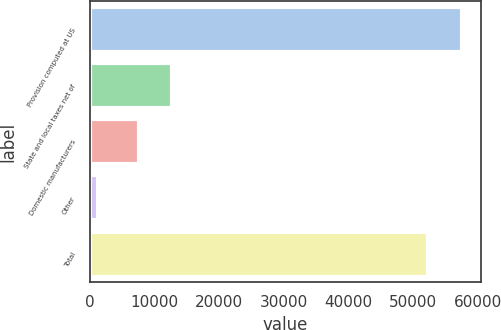Convert chart to OTSL. <chart><loc_0><loc_0><loc_500><loc_500><bar_chart><fcel>Provision computed at US<fcel>State and local taxes net of<fcel>Domestic manufacturers<fcel>Other<fcel>Total<nl><fcel>57561<fcel>12770<fcel>7540<fcel>1286<fcel>52331<nl></chart> 